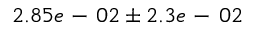<formula> <loc_0><loc_0><loc_500><loc_500>2 . 8 5 e - 0 2 \pm 2 . 3 e - 0 2</formula> 